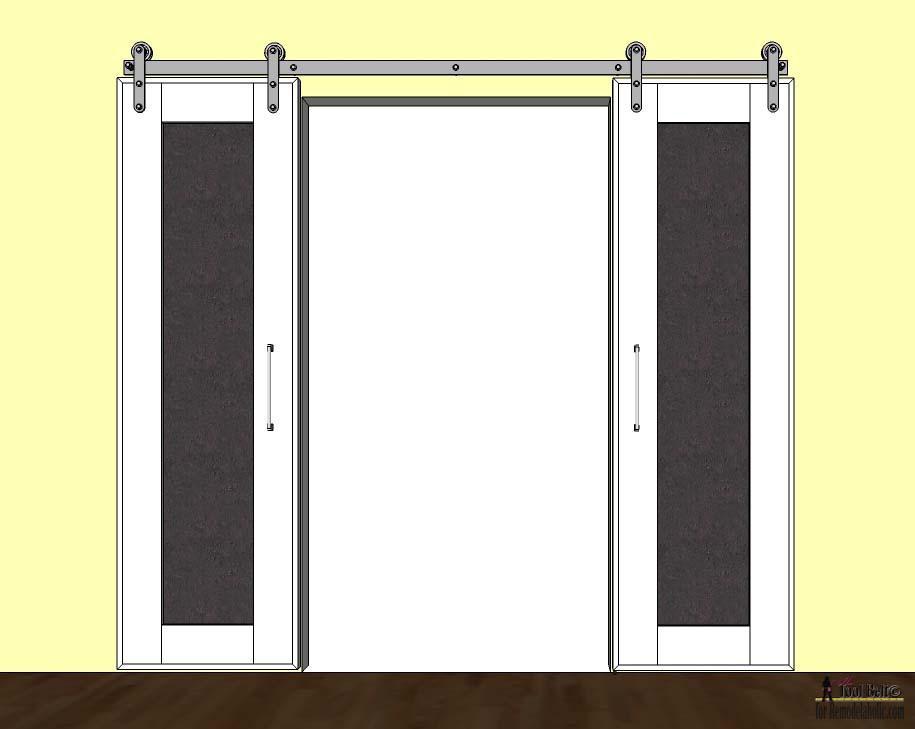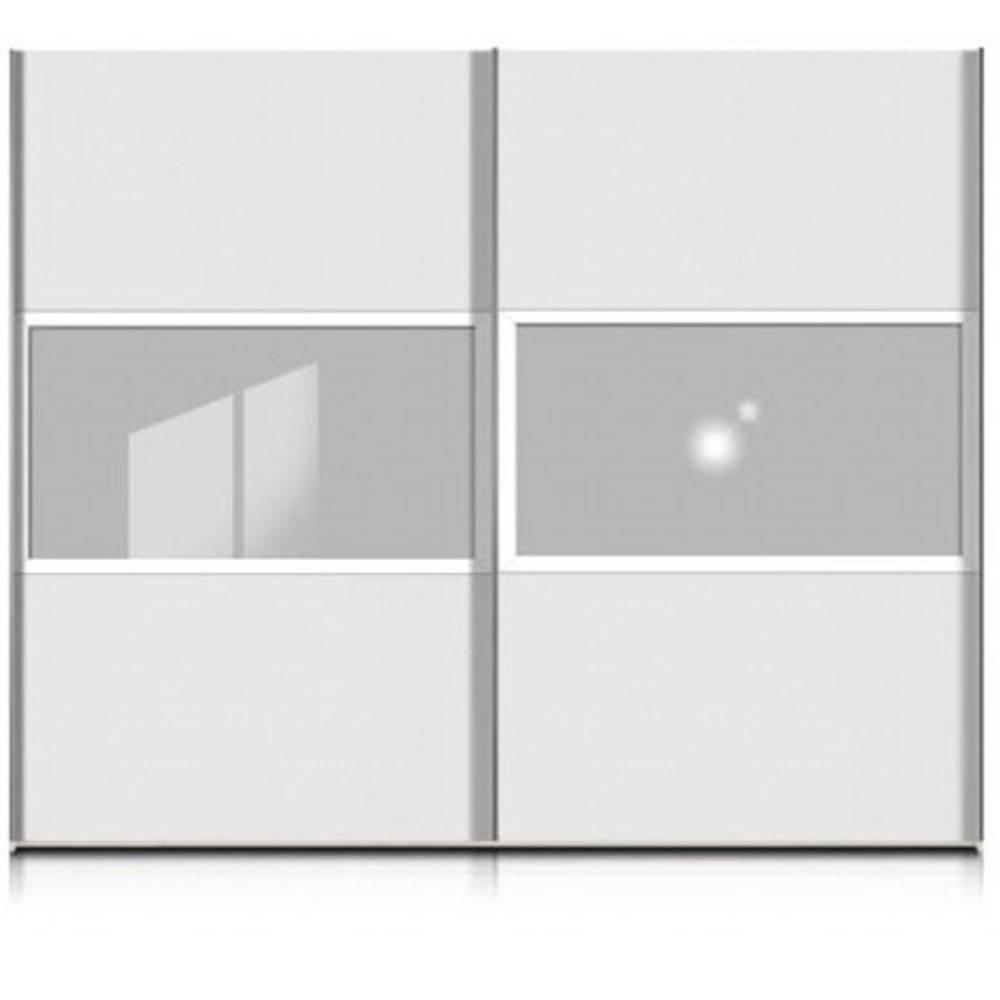The first image is the image on the left, the second image is the image on the right. Examine the images to the left and right. Is the description "One design shows a door with a white center section and colored sections flanking it." accurate? Answer yes or no. Yes. The first image is the image on the left, the second image is the image on the right. For the images displayed, is the sentence "there is a dark wooded floor in the image on the right" factually correct? Answer yes or no. No. 